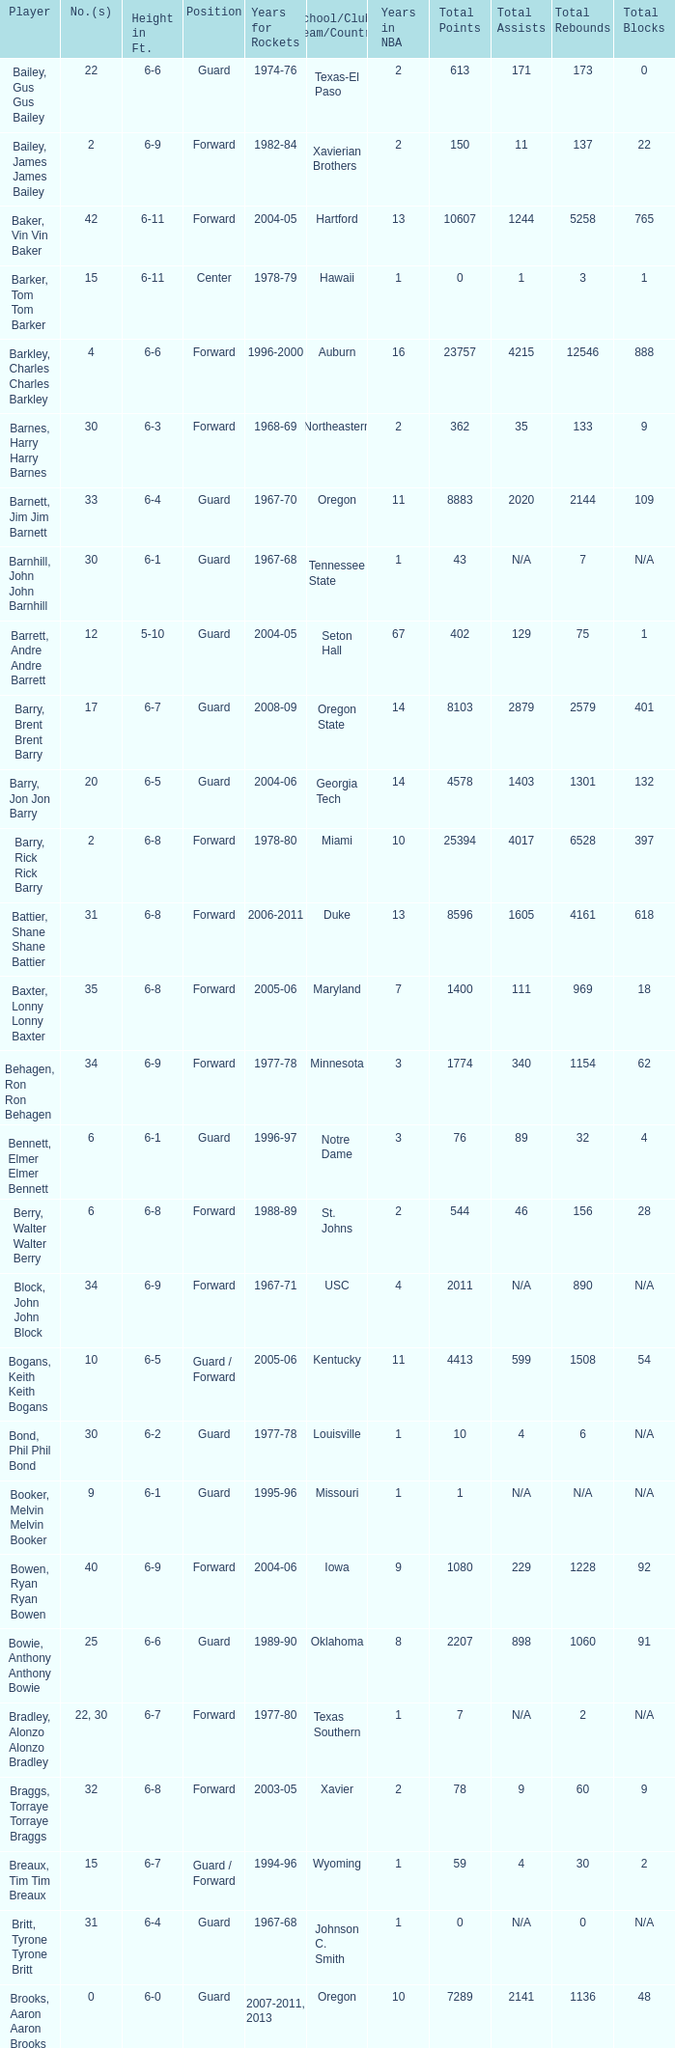Could you parse the entire table as a dict? {'header': ['Player', 'No.(s)', 'Height in Ft.', 'Position', 'Years for Rockets', 'School/Club Team/Country', 'Years in NBA', 'Total Points', 'Total Assists', 'Total Rebounds', 'Total Blocks'], 'rows': [['Bailey, Gus Gus Bailey', '22', '6-6', 'Guard', '1974-76', 'Texas-El Paso', '2', '613', '171', '173', '0'], ['Bailey, James James Bailey', '2', '6-9', 'Forward', '1982-84', 'Xavierian Brothers', '2', '150', '11', '137', '22'], ['Baker, Vin Vin Baker', '42', '6-11', 'Forward', '2004-05', 'Hartford', '13', '10607', '1244', '5258', '765'], ['Barker, Tom Tom Barker', '15', '6-11', 'Center', '1978-79', 'Hawaii', '1', '0', '1', '3', '1'], ['Barkley, Charles Charles Barkley', '4', '6-6', 'Forward', '1996-2000', 'Auburn', '16', '23757', '4215', '12546', '888'], ['Barnes, Harry Harry Barnes', '30', '6-3', 'Forward', '1968-69', 'Northeastern', '2', '362', '35', '133', '9'], ['Barnett, Jim Jim Barnett', '33', '6-4', 'Guard', '1967-70', 'Oregon', '11', '8883', '2020', '2144', '109'], ['Barnhill, John John Barnhill', '30', '6-1', 'Guard', '1967-68', 'Tennessee State', '1', '43', 'N/A', '7', 'N/A'], ['Barrett, Andre Andre Barrett', '12', '5-10', 'Guard', '2004-05', 'Seton Hall', '67', '402', '129', '75', '1'], ['Barry, Brent Brent Barry', '17', '6-7', 'Guard', '2008-09', 'Oregon State', '14', '8103', '2879', '2579', '401'], ['Barry, Jon Jon Barry', '20', '6-5', 'Guard', '2004-06', 'Georgia Tech', '14', '4578', '1403', '1301', '132'], ['Barry, Rick Rick Barry', '2', '6-8', 'Forward', '1978-80', 'Miami', '10', '25394', '4017', '6528', '397'], ['Battier, Shane Shane Battier', '31', '6-8', 'Forward', '2006-2011', 'Duke', '13', '8596', '1605', '4161', '618'], ['Baxter, Lonny Lonny Baxter', '35', '6-8', 'Forward', '2005-06', 'Maryland', '7', '1400', '111', '969', '18'], ['Behagen, Ron Ron Behagen', '34', '6-9', 'Forward', '1977-78', 'Minnesota', '3', '1774', '340', '1154', '62'], ['Bennett, Elmer Elmer Bennett', '6', '6-1', 'Guard', '1996-97', 'Notre Dame', '3', '76', '89', '32', '4'], ['Berry, Walter Walter Berry', '6', '6-8', 'Forward', '1988-89', 'St. Johns', '2', '544', '46', '156', '28'], ['Block, John John Block', '34', '6-9', 'Forward', '1967-71', 'USC', '4', '2011', 'N/A', '890', 'N/A'], ['Bogans, Keith Keith Bogans', '10', '6-5', 'Guard / Forward', '2005-06', 'Kentucky', '11', '4413', '599', '1508', '54'], ['Bond, Phil Phil Bond', '30', '6-2', 'Guard', '1977-78', 'Louisville', '1', '10', '4', '6', 'N/A'], ['Booker, Melvin Melvin Booker', '9', '6-1', 'Guard', '1995-96', 'Missouri', '1', '1', 'N/A', 'N/A', 'N/A'], ['Bowen, Ryan Ryan Bowen', '40', '6-9', 'Forward', '2004-06', 'Iowa', '9', '1080', '229', '1228', '92'], ['Bowie, Anthony Anthony Bowie', '25', '6-6', 'Guard', '1989-90', 'Oklahoma', '8', '2207', '898', '1060', '91'], ['Bradley, Alonzo Alonzo Bradley', '22, 30', '6-7', 'Forward', '1977-80', 'Texas Southern', '1', '7', 'N/A', '2', 'N/A'], ['Braggs, Torraye Torraye Braggs', '32', '6-8', 'Forward', '2003-05', 'Xavier', '2', '78', '9', '60', '9'], ['Breaux, Tim Tim Breaux', '15', '6-7', 'Guard / Forward', '1994-96', 'Wyoming', '1', '59', '4', '30', '2'], ['Britt, Tyrone Tyrone Britt', '31', '6-4', 'Guard', '1967-68', 'Johnson C. Smith', '1', '0', 'N/A', '0', 'N/A'], ['Brooks, Aaron Aaron Brooks', '0', '6-0', 'Guard', '2007-2011, 2013', 'Oregon', '10', '7289', '2141', '1136', '48'], ['Brooks, Scott Scott Brooks', '1', '5-11', 'Guard', '1992-95', 'UC-Irvine', '10', '2327', '820', '714', '38'], ['Brown, Chucky Chucky Brown', '52', '6-8', 'Forward', '1994-96', 'North Carolina', '13', '6090', '818', '2683', '364'], ['Brown, Tony Tony Brown', '35', '6-6', 'Forward', '1988-89', 'Arkansas', '2', '41', '6', '23', '4'], ['Brown, Tierre Tierre Brown', '10', '6-2', 'Guard', '2001-02', 'McNesse State', '1', '58', '4', '13', '0'], ['Brunson, Rick Rick Brunson', '9', '6-4', 'Guard', '2005-06', 'Temple', '9', '3007', '1156', '903', '36'], ['Bryant, Joe Joe Bryant', '22', '6-9', 'Forward / Guard', '1982-83', 'LaSalle', '8', '4031', '811', '1509', '113'], ['Bryant, Mark Mark Bryant', '2', '6-9', 'Forward', '1995-96', 'Seton Hall', '8', '2525', '477', '1237', '47'], ['Budinger, Chase Chase Budinger', '10', '6-7', 'Forward', '2009-2012', 'Arizona', '7', '3156', '461', '1301', '78'], ['Bullard, Matt Matt Bullard', '50', '6-10', 'Forward', '1990-94, 1996-2001', 'Iowa', '11', '4673', '830', '2060', '232']]} What school did the forward whose number is 10 belong to? Arizona. 